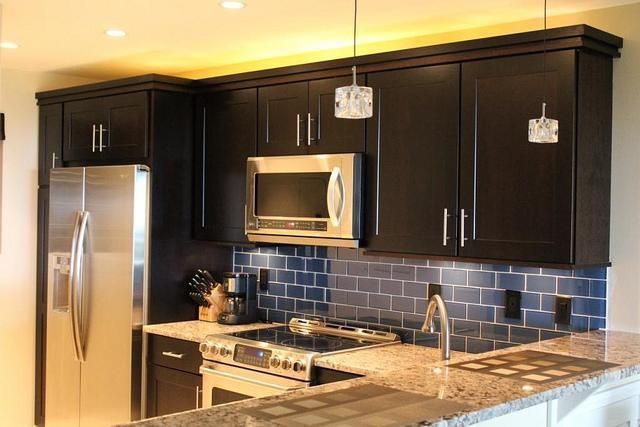What does the item with silver doors regulate?
Choose the right answer from the provided options to respond to the question.
Options: Humidity, bacterial content, temperature, blood pressure. Temperature. 